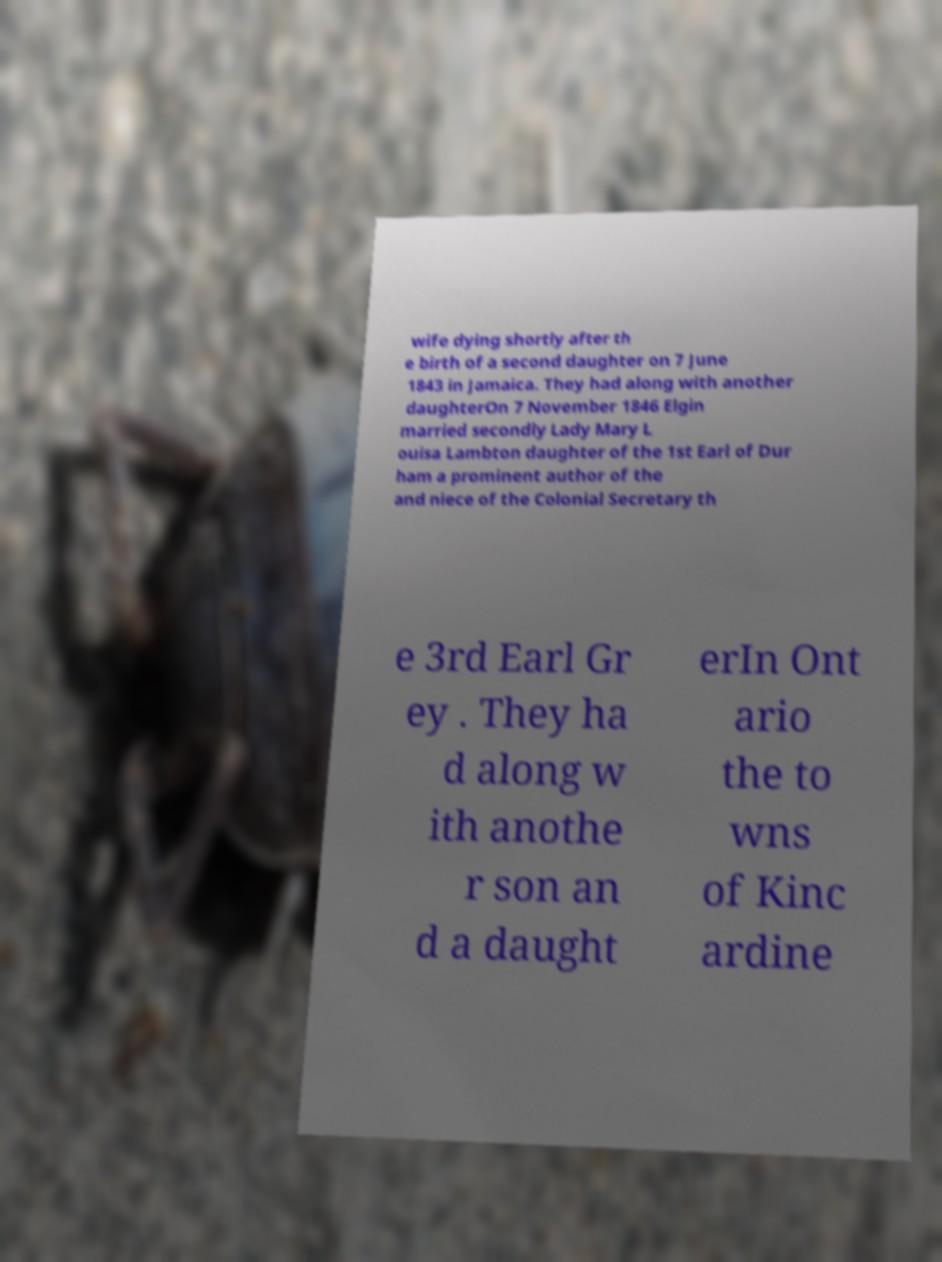Could you assist in decoding the text presented in this image and type it out clearly? wife dying shortly after th e birth of a second daughter on 7 June 1843 in Jamaica. They had along with another daughterOn 7 November 1846 Elgin married secondly Lady Mary L ouisa Lambton daughter of the 1st Earl of Dur ham a prominent author of the and niece of the Colonial Secretary th e 3rd Earl Gr ey . They ha d along w ith anothe r son an d a daught erIn Ont ario the to wns of Kinc ardine 